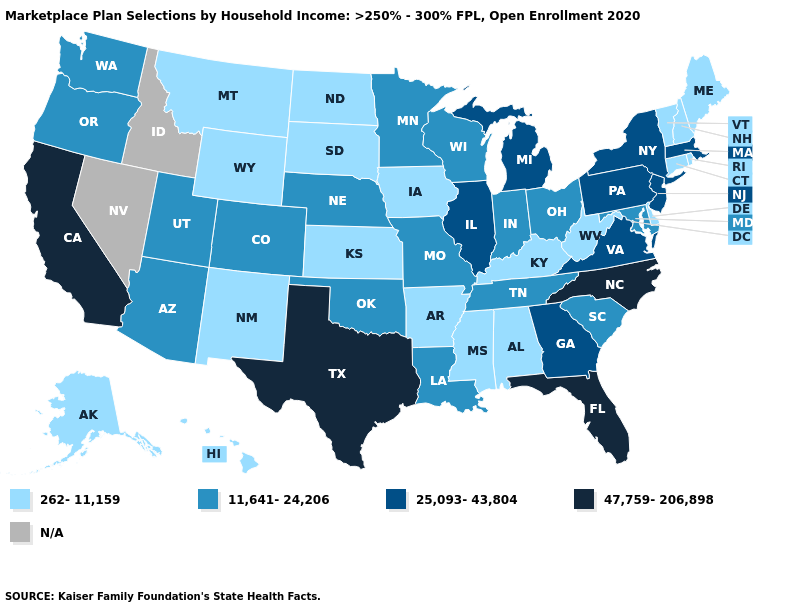What is the value of Maine?
Quick response, please. 262-11,159. What is the value of New Hampshire?
Keep it brief. 262-11,159. Among the states that border Rhode Island , which have the highest value?
Be succinct. Massachusetts. Name the states that have a value in the range 11,641-24,206?
Be succinct. Arizona, Colorado, Indiana, Louisiana, Maryland, Minnesota, Missouri, Nebraska, Ohio, Oklahoma, Oregon, South Carolina, Tennessee, Utah, Washington, Wisconsin. What is the highest value in the USA?
Give a very brief answer. 47,759-206,898. What is the value of New Jersey?
Answer briefly. 25,093-43,804. Which states have the lowest value in the USA?
Be succinct. Alabama, Alaska, Arkansas, Connecticut, Delaware, Hawaii, Iowa, Kansas, Kentucky, Maine, Mississippi, Montana, New Hampshire, New Mexico, North Dakota, Rhode Island, South Dakota, Vermont, West Virginia, Wyoming. Name the states that have a value in the range 25,093-43,804?
Short answer required. Georgia, Illinois, Massachusetts, Michigan, New Jersey, New York, Pennsylvania, Virginia. Name the states that have a value in the range 11,641-24,206?
Keep it brief. Arizona, Colorado, Indiana, Louisiana, Maryland, Minnesota, Missouri, Nebraska, Ohio, Oklahoma, Oregon, South Carolina, Tennessee, Utah, Washington, Wisconsin. Name the states that have a value in the range N/A?
Give a very brief answer. Idaho, Nevada. Does the first symbol in the legend represent the smallest category?
Be succinct. Yes. Does Massachusetts have the lowest value in the Northeast?
Be succinct. No. Name the states that have a value in the range 11,641-24,206?
Short answer required. Arizona, Colorado, Indiana, Louisiana, Maryland, Minnesota, Missouri, Nebraska, Ohio, Oklahoma, Oregon, South Carolina, Tennessee, Utah, Washington, Wisconsin. Among the states that border Michigan , which have the lowest value?
Be succinct. Indiana, Ohio, Wisconsin. 